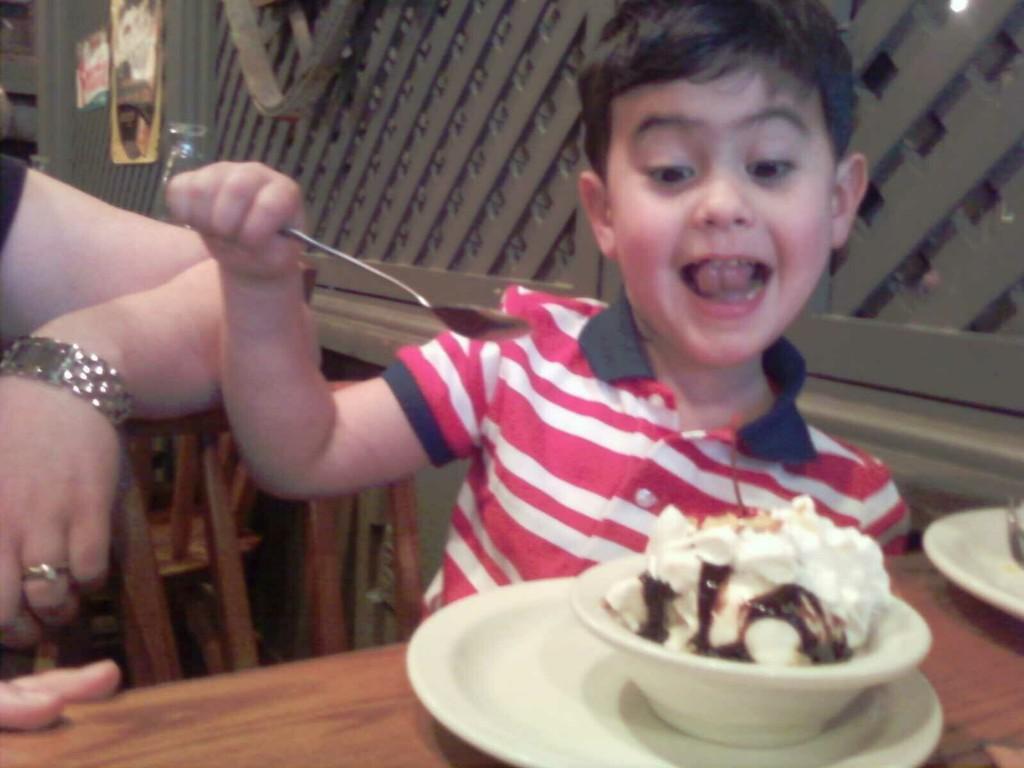Please provide a concise description of this image. In this picture there is a boy who is holding a spoon. He is sitting on the chair near to the table. On the table I can see the cup, bowl and ice cream. On the left I can see the women's hand who is wearing t-shirt, watch and finger ring. On the top left corner I can see the posts which are placed on the wooden fencing. 